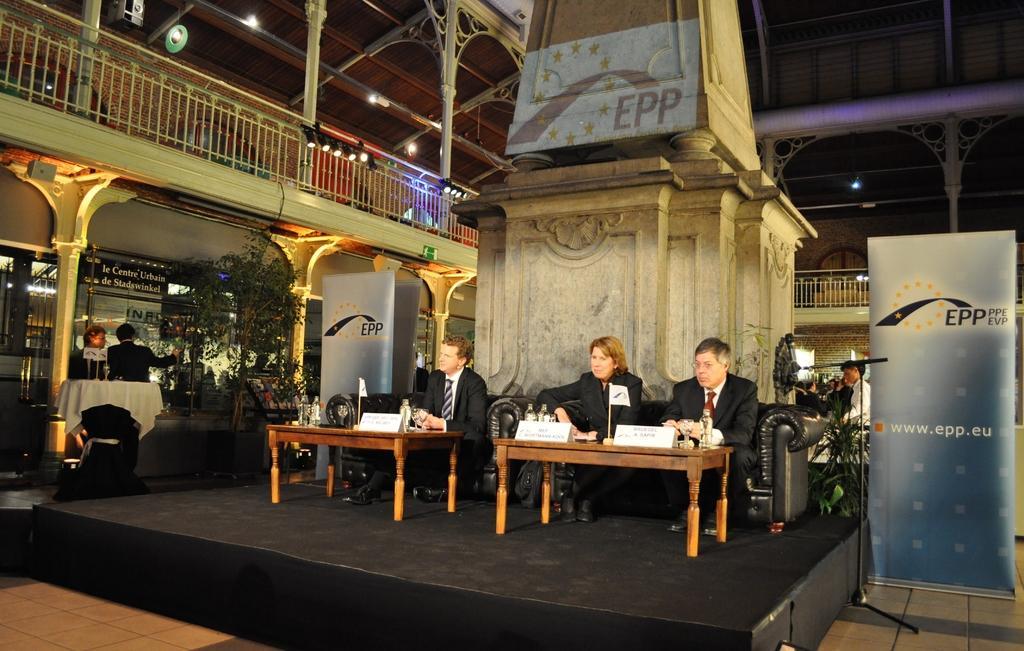How would you summarize this image in a sentence or two? Two men and a woman are sitting in sofa at two tables on a stage. There are few people around them. 